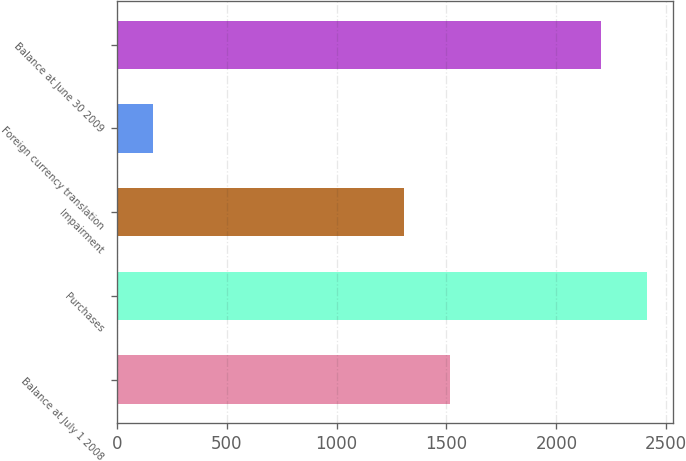<chart> <loc_0><loc_0><loc_500><loc_500><bar_chart><fcel>Balance at July 1 2008<fcel>Purchases<fcel>Impairment<fcel>Foreign currency translation<fcel>Balance at June 30 2009<nl><fcel>1516.2<fcel>2411.2<fcel>1306<fcel>165<fcel>2201<nl></chart> 